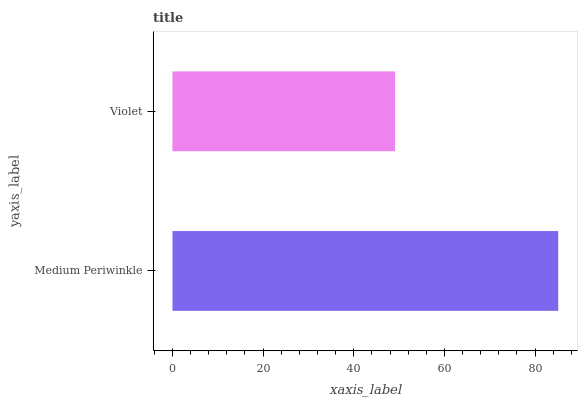Is Violet the minimum?
Answer yes or no. Yes. Is Medium Periwinkle the maximum?
Answer yes or no. Yes. Is Violet the maximum?
Answer yes or no. No. Is Medium Periwinkle greater than Violet?
Answer yes or no. Yes. Is Violet less than Medium Periwinkle?
Answer yes or no. Yes. Is Violet greater than Medium Periwinkle?
Answer yes or no. No. Is Medium Periwinkle less than Violet?
Answer yes or no. No. Is Medium Periwinkle the high median?
Answer yes or no. Yes. Is Violet the low median?
Answer yes or no. Yes. Is Violet the high median?
Answer yes or no. No. Is Medium Periwinkle the low median?
Answer yes or no. No. 